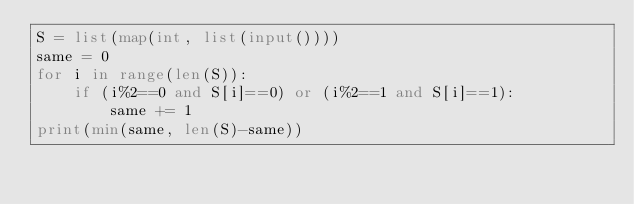<code> <loc_0><loc_0><loc_500><loc_500><_Python_>S = list(map(int, list(input())))
same = 0
for i in range(len(S)):
    if (i%2==0 and S[i]==0) or (i%2==1 and S[i]==1):
        same += 1
print(min(same, len(S)-same))
</code> 